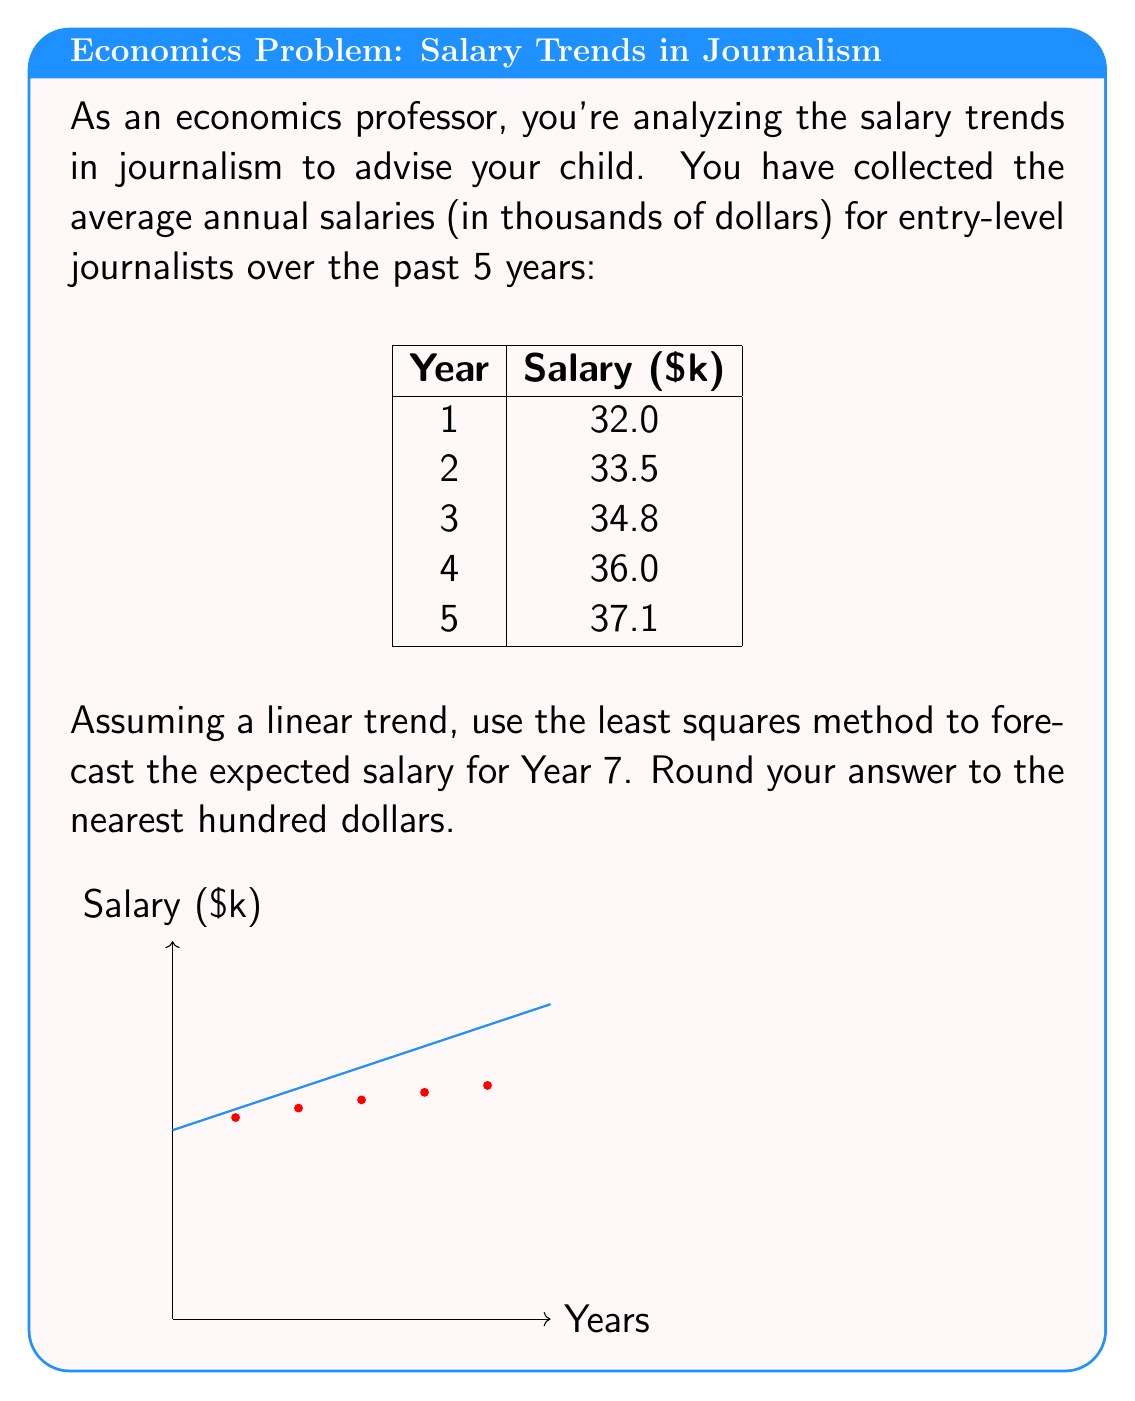Could you help me with this problem? To forecast the salary using the least squares method, we need to follow these steps:

1) Calculate the means of x (years) and y (salaries):
   $\bar{x} = \frac{1+2+3+4+5}{5} = 3$
   $\bar{y} = \frac{32+33.5+34.8+36+37.1}{5} = 34.68$

2) Calculate $\sum (x_i - \bar{x})(y_i - \bar{y})$ and $\sum (x_i - \bar{x})^2$:
   $\sum (x_i - \bar{x})(y_i - \bar{y}) = 10.65$
   $\sum (x_i - \bar{x})^2 = 10$

3) Find the slope (m) of the line:
   $m = \frac{\sum (x_i - \bar{x})(y_i - \bar{y})}{\sum (x_i - \bar{x})^2} = \frac{10.65}{10} = 1.065$

4) Find the y-intercept (b) using $y = mx + b$:
   $34.68 = 1.065(3) + b$
   $b = 34.68 - 3.195 = 31.485$

5) The linear equation is:
   $y = 1.065x + 31.485$

6) For Year 7, x = 7:
   $y = 1.065(7) + 31.485 = 38.94$

Therefore, the forecasted salary for Year 7 is $38,940, rounded to $38,900.
Answer: $38,900 